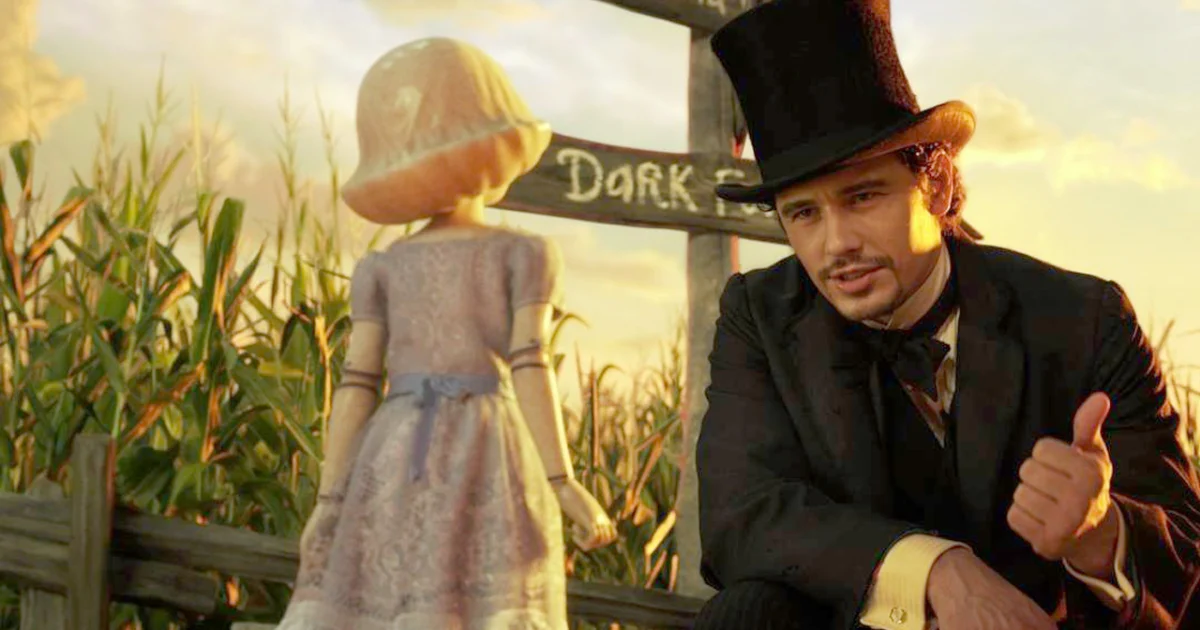Can you describe the significance of the setting in this scene? Certainly! The cornfield setting at sunset provides a picturesque yet symbolically rich backdrop. Such environments are often associated with fertility and growth, which subtly complements the film's themes of personal and magical transformation. The warm tones of sunset suggest a transitional time, which could symbolize change or evolution in the characters' journey. How does the interaction between the characters develop their relationship in the storyline? This interaction deepens the bond between Oz and China Girl. Oz’s protective and gentle demeanor helps build trust, portraying him as a mentor and guardian figure. This moment strengthens their camaraderie, pivotal for their collaboration in overcoming upcoming challenges in the plot. 